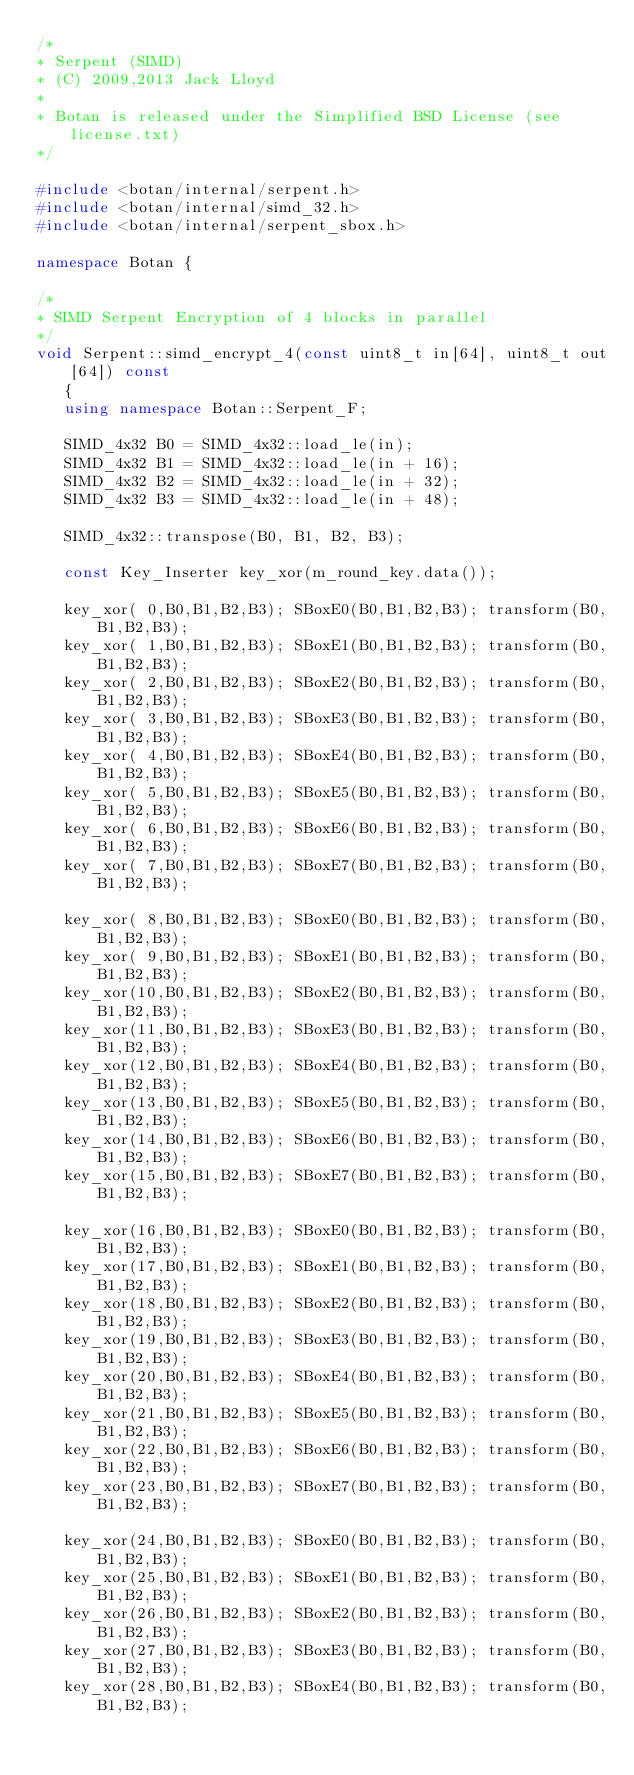<code> <loc_0><loc_0><loc_500><loc_500><_C++_>/*
* Serpent (SIMD)
* (C) 2009,2013 Jack Lloyd
*
* Botan is released under the Simplified BSD License (see license.txt)
*/

#include <botan/internal/serpent.h>
#include <botan/internal/simd_32.h>
#include <botan/internal/serpent_sbox.h>

namespace Botan {

/*
* SIMD Serpent Encryption of 4 blocks in parallel
*/
void Serpent::simd_encrypt_4(const uint8_t in[64], uint8_t out[64]) const
   {
   using namespace Botan::Serpent_F;

   SIMD_4x32 B0 = SIMD_4x32::load_le(in);
   SIMD_4x32 B1 = SIMD_4x32::load_le(in + 16);
   SIMD_4x32 B2 = SIMD_4x32::load_le(in + 32);
   SIMD_4x32 B3 = SIMD_4x32::load_le(in + 48);

   SIMD_4x32::transpose(B0, B1, B2, B3);

   const Key_Inserter key_xor(m_round_key.data());

   key_xor( 0,B0,B1,B2,B3); SBoxE0(B0,B1,B2,B3); transform(B0,B1,B2,B3);
   key_xor( 1,B0,B1,B2,B3); SBoxE1(B0,B1,B2,B3); transform(B0,B1,B2,B3);
   key_xor( 2,B0,B1,B2,B3); SBoxE2(B0,B1,B2,B3); transform(B0,B1,B2,B3);
   key_xor( 3,B0,B1,B2,B3); SBoxE3(B0,B1,B2,B3); transform(B0,B1,B2,B3);
   key_xor( 4,B0,B1,B2,B3); SBoxE4(B0,B1,B2,B3); transform(B0,B1,B2,B3);
   key_xor( 5,B0,B1,B2,B3); SBoxE5(B0,B1,B2,B3); transform(B0,B1,B2,B3);
   key_xor( 6,B0,B1,B2,B3); SBoxE6(B0,B1,B2,B3); transform(B0,B1,B2,B3);
   key_xor( 7,B0,B1,B2,B3); SBoxE7(B0,B1,B2,B3); transform(B0,B1,B2,B3);

   key_xor( 8,B0,B1,B2,B3); SBoxE0(B0,B1,B2,B3); transform(B0,B1,B2,B3);
   key_xor( 9,B0,B1,B2,B3); SBoxE1(B0,B1,B2,B3); transform(B0,B1,B2,B3);
   key_xor(10,B0,B1,B2,B3); SBoxE2(B0,B1,B2,B3); transform(B0,B1,B2,B3);
   key_xor(11,B0,B1,B2,B3); SBoxE3(B0,B1,B2,B3); transform(B0,B1,B2,B3);
   key_xor(12,B0,B1,B2,B3); SBoxE4(B0,B1,B2,B3); transform(B0,B1,B2,B3);
   key_xor(13,B0,B1,B2,B3); SBoxE5(B0,B1,B2,B3); transform(B0,B1,B2,B3);
   key_xor(14,B0,B1,B2,B3); SBoxE6(B0,B1,B2,B3); transform(B0,B1,B2,B3);
   key_xor(15,B0,B1,B2,B3); SBoxE7(B0,B1,B2,B3); transform(B0,B1,B2,B3);

   key_xor(16,B0,B1,B2,B3); SBoxE0(B0,B1,B2,B3); transform(B0,B1,B2,B3);
   key_xor(17,B0,B1,B2,B3); SBoxE1(B0,B1,B2,B3); transform(B0,B1,B2,B3);
   key_xor(18,B0,B1,B2,B3); SBoxE2(B0,B1,B2,B3); transform(B0,B1,B2,B3);
   key_xor(19,B0,B1,B2,B3); SBoxE3(B0,B1,B2,B3); transform(B0,B1,B2,B3);
   key_xor(20,B0,B1,B2,B3); SBoxE4(B0,B1,B2,B3); transform(B0,B1,B2,B3);
   key_xor(21,B0,B1,B2,B3); SBoxE5(B0,B1,B2,B3); transform(B0,B1,B2,B3);
   key_xor(22,B0,B1,B2,B3); SBoxE6(B0,B1,B2,B3); transform(B0,B1,B2,B3);
   key_xor(23,B0,B1,B2,B3); SBoxE7(B0,B1,B2,B3); transform(B0,B1,B2,B3);

   key_xor(24,B0,B1,B2,B3); SBoxE0(B0,B1,B2,B3); transform(B0,B1,B2,B3);
   key_xor(25,B0,B1,B2,B3); SBoxE1(B0,B1,B2,B3); transform(B0,B1,B2,B3);
   key_xor(26,B0,B1,B2,B3); SBoxE2(B0,B1,B2,B3); transform(B0,B1,B2,B3);
   key_xor(27,B0,B1,B2,B3); SBoxE3(B0,B1,B2,B3); transform(B0,B1,B2,B3);
   key_xor(28,B0,B1,B2,B3); SBoxE4(B0,B1,B2,B3); transform(B0,B1,B2,B3);</code> 